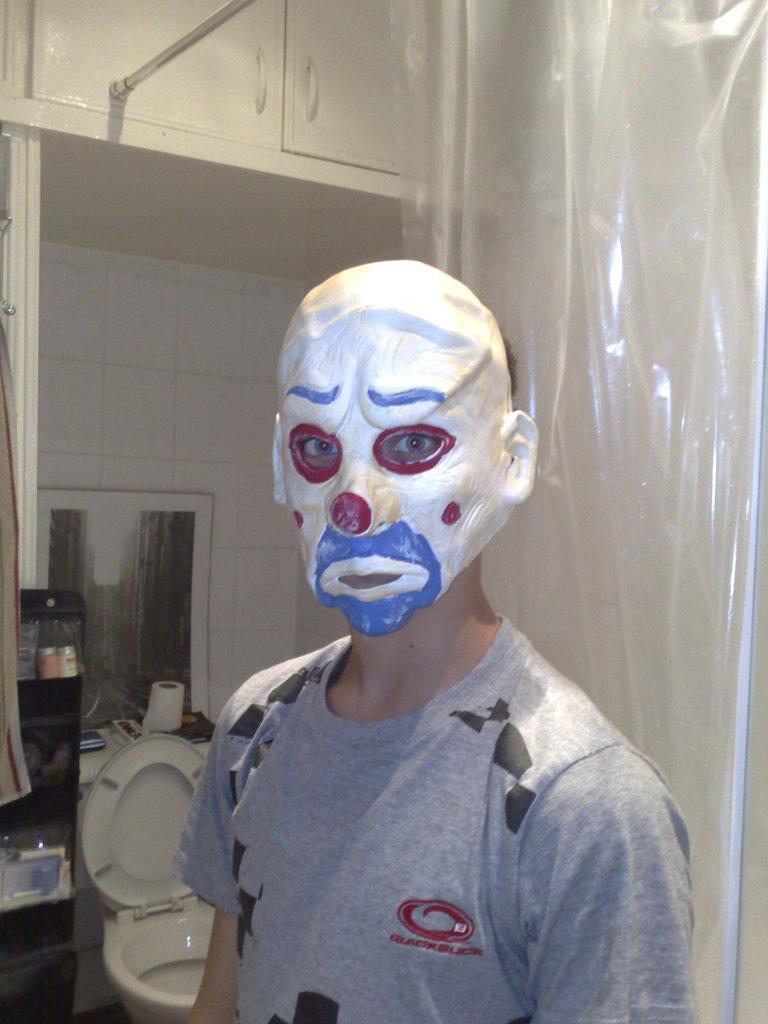Could you give a brief overview of what you see in this image? In the picture a person is standing in a washroom, he is wearing a mask and behind him there is a toilet seat and there is a plastic curtain and there are some objects kept beside the toilet seat and above the tiles there are two cupboards 